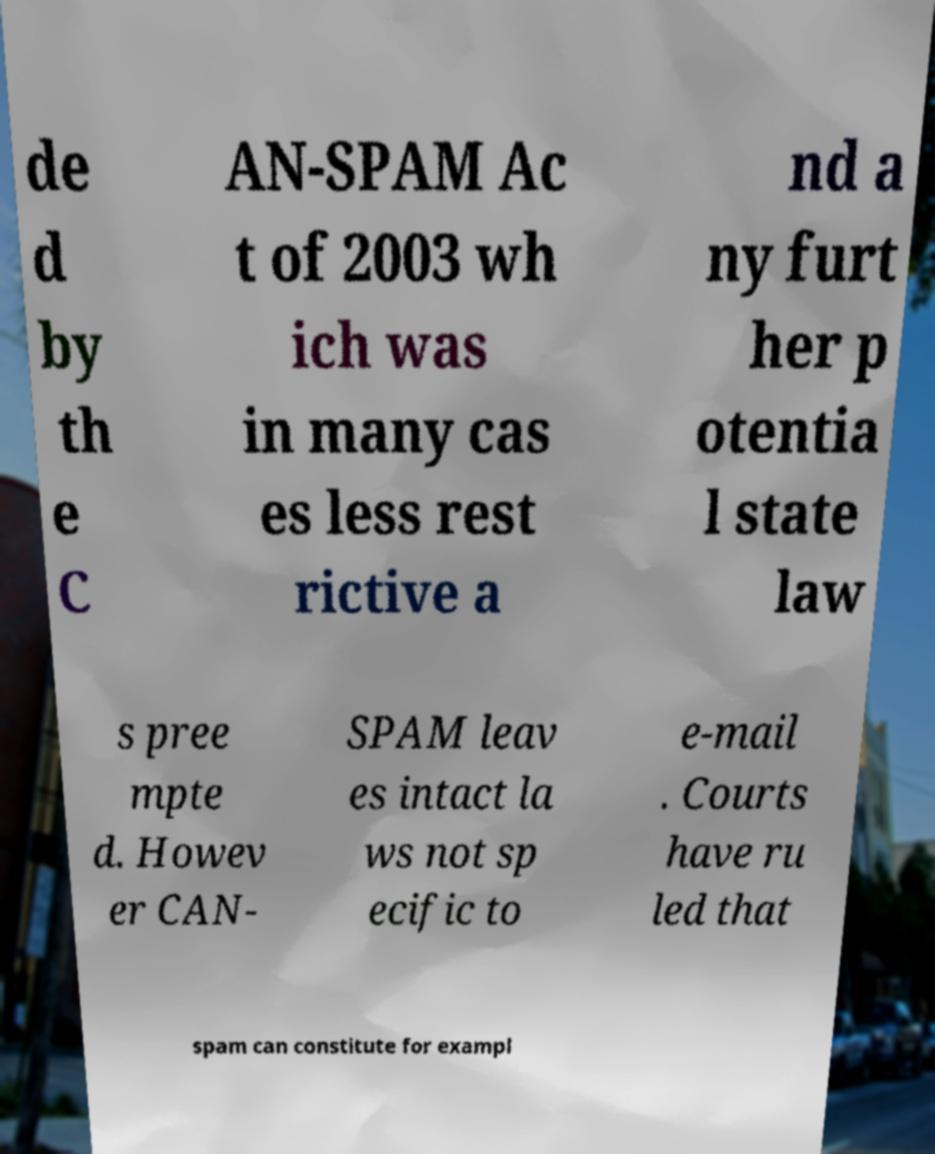Please identify and transcribe the text found in this image. de d by th e C AN-SPAM Ac t of 2003 wh ich was in many cas es less rest rictive a nd a ny furt her p otentia l state law s pree mpte d. Howev er CAN- SPAM leav es intact la ws not sp ecific to e-mail . Courts have ru led that spam can constitute for exampl 